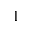Convert formula to latex. <formula><loc_0><loc_0><loc_500><loc_500>1</formula> 